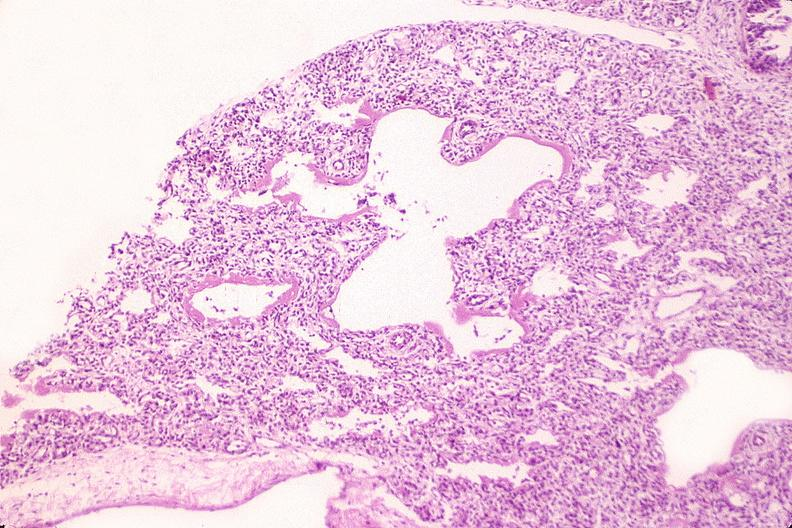s respiratory present?
Answer the question using a single word or phrase. Yes 